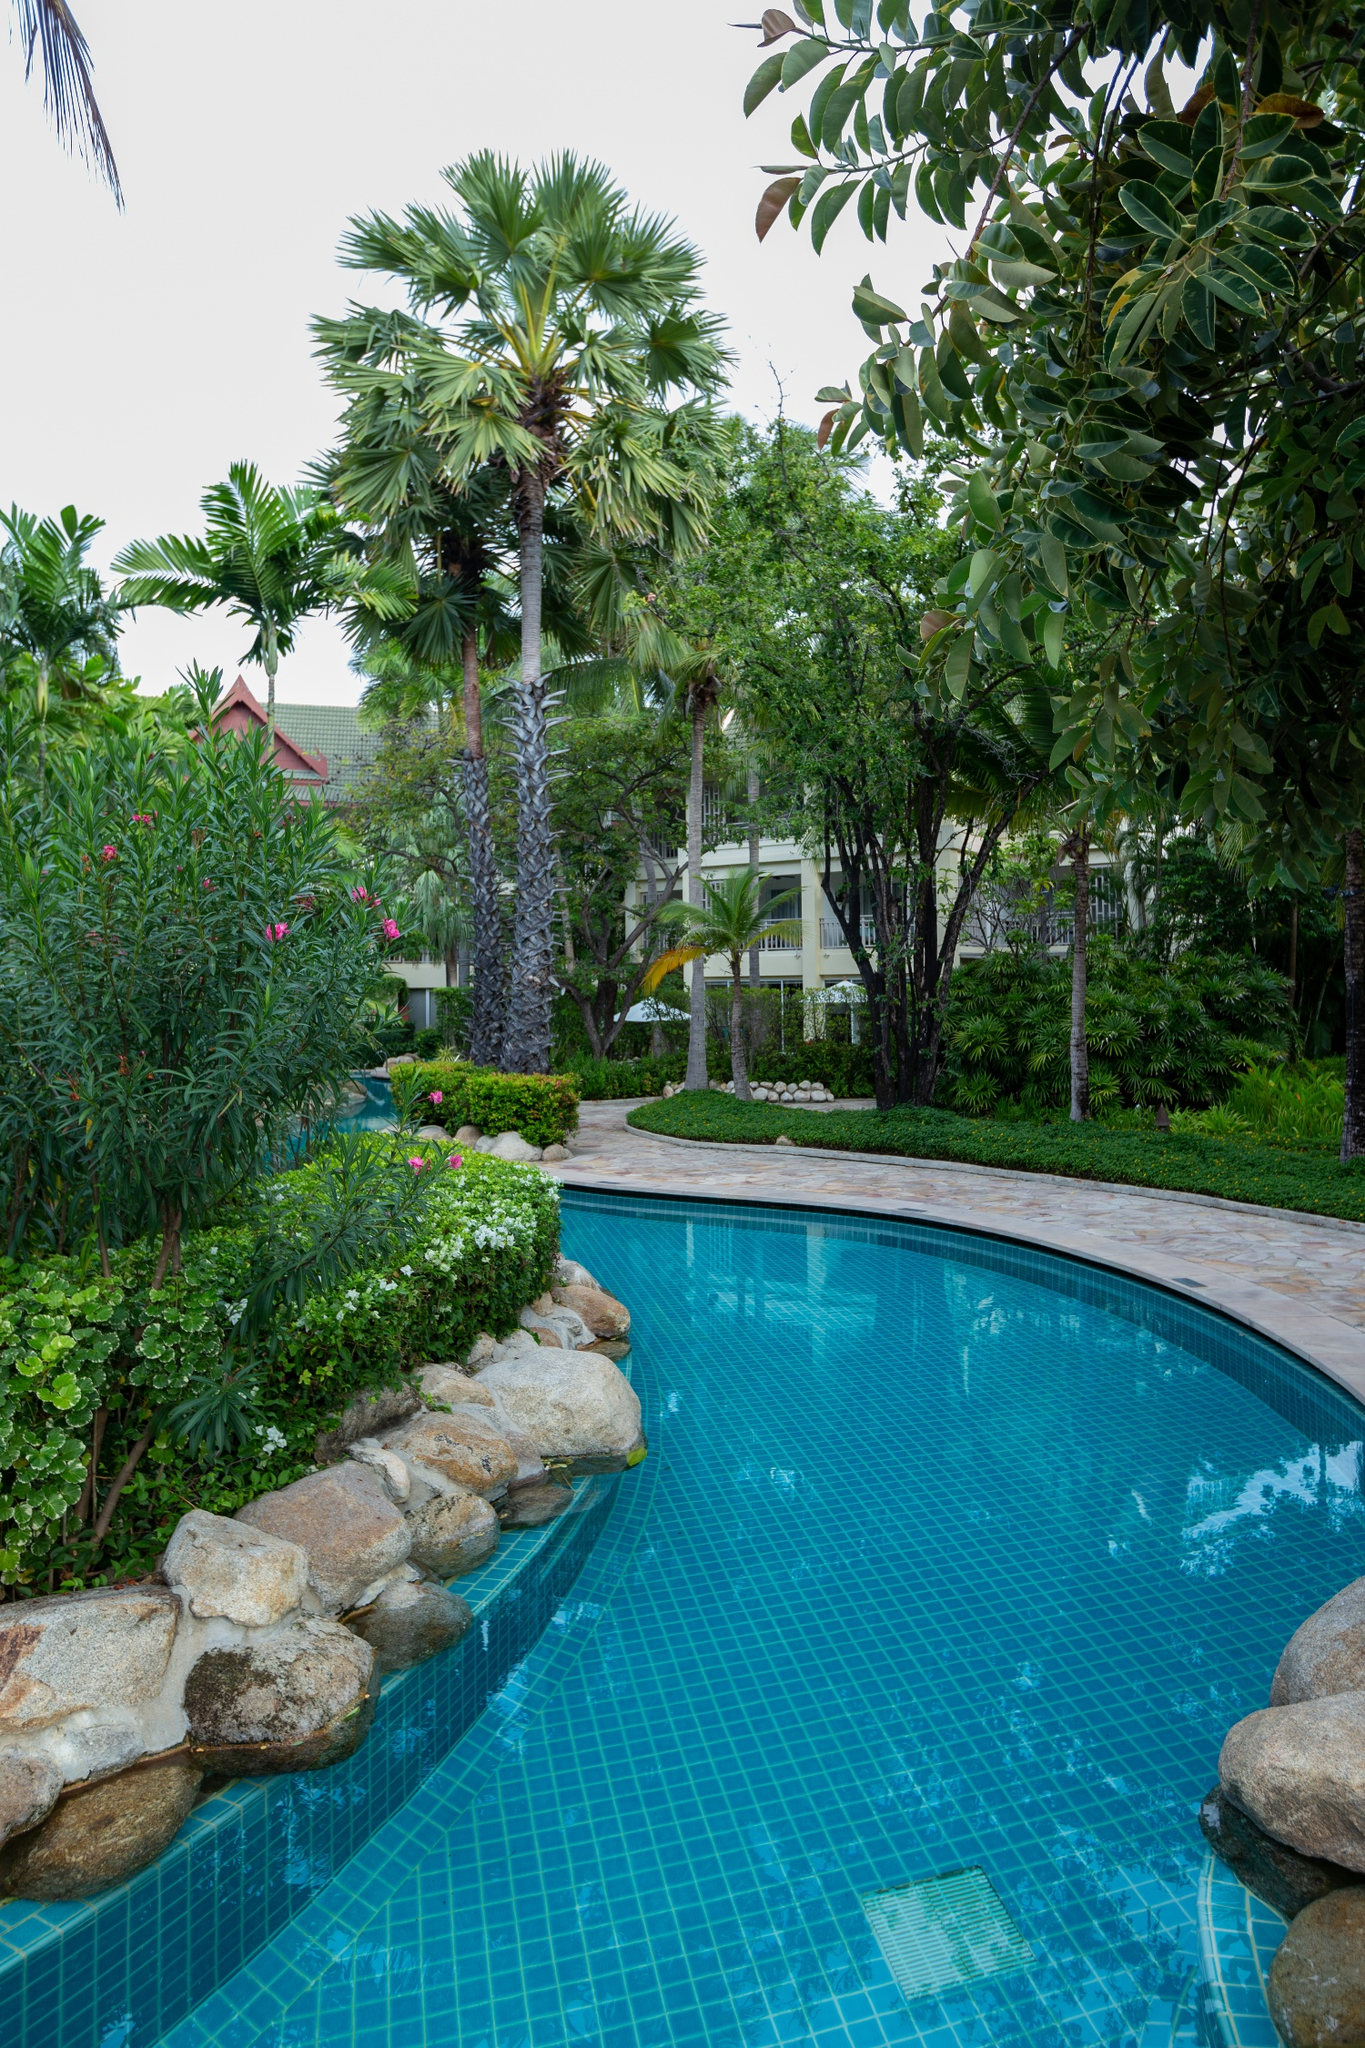Imagine if this place had a secret hidden within the garden. What could it be? Legend has it that deep within this lush, tropical garden lies a secret that has been guarded for centuries. Hidden beneath the oldest and grandest palm tree, there's a concealed trapdoor, leading to an underground sanctuary. This sanctuary, known only to the resort’s founders, is a hidden oasis of rare botanical treasures and ancient artifacts. Illuminated by glowing crystal lanterns that never dim, the sanctuary houses plants that bloom only once every century, releasing fragrances that are said to rejuvenate the soul. Among these wonders is a legendary map, etched in gold, rumored to lead to a fountain of youth. Resort guests remain blissfully unaware of this hidden treasure, enjoying the natural beauty above. But for those with an adventurous spirit and a keen eye for detail, subtle clues scattered throughout the garden promise to reveal the path to this extraordinary discovery, offering an experience unlike any other. Describe a typical day for the guests at this resort, from morning until night. A typical day at this enchanting resort begins with the sun casting its first light over the pristine swimming pool, waking the garden into a vibrant display of colors. Guests rise to the chirping of birds and the scent of blooming flowers, greeted with a luxurious breakfast on the terrace, featuring fresh fruits, pastries, and aromatic coffee. The morning is perfect for a refreshing swim or a peaceful stroll amidst the lush greenery. As the day progresses, guests might indulge in a spa treatment, partake in a yoga session by the pool, or explore the nearby nature trails. Lunchtime offers delectable dishes prepared from local ingredients, served under the shade of palm trees. The afternoon is reserved for leisurely activities like reading by the poolside, taking a nap in a hammock, or perhaps engaging in a friendly game of tennis. As evening approaches, the resort transforms into a magical wonderland with soft lights illuminating the garden. Guests gather for a gourmet dinner under the stars, sharing stories and laughter. The night may end with a soothing dip in the pool, a walk along the winding garden paths, or simply gazing at the starry sky. It’s a seamless blend of relaxation, luxury, and connection with nature, ensuring every moment is cherished. 